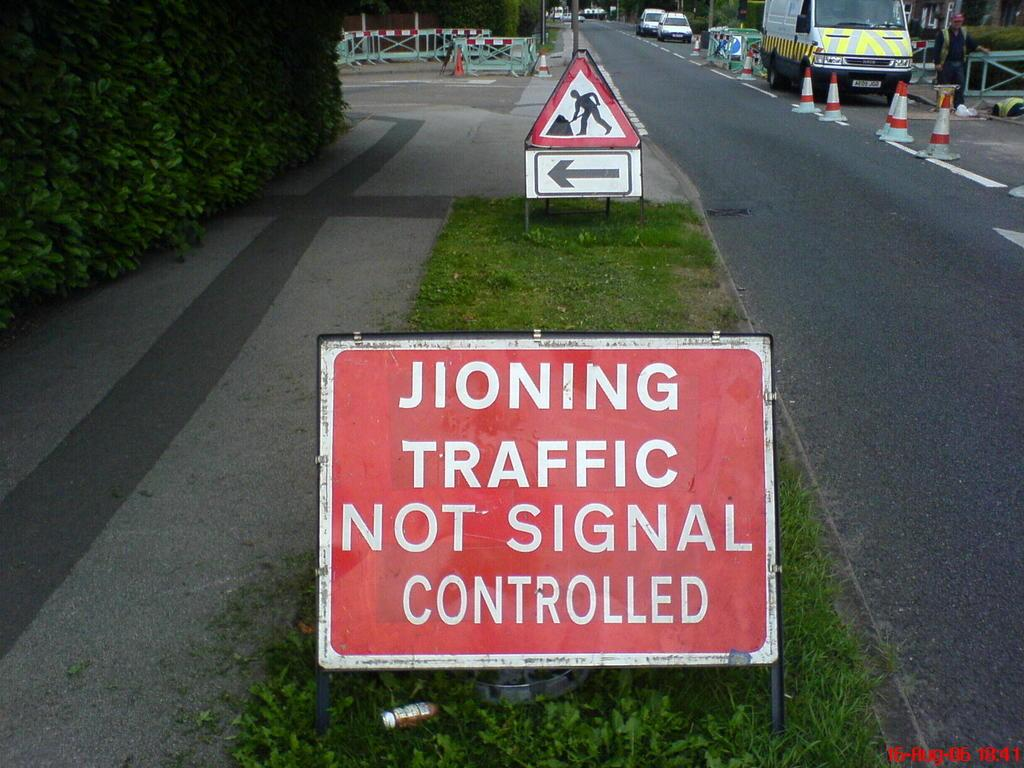<image>
Relay a brief, clear account of the picture shown. Red sign on some grass which says "Traffic not signal controlled". 